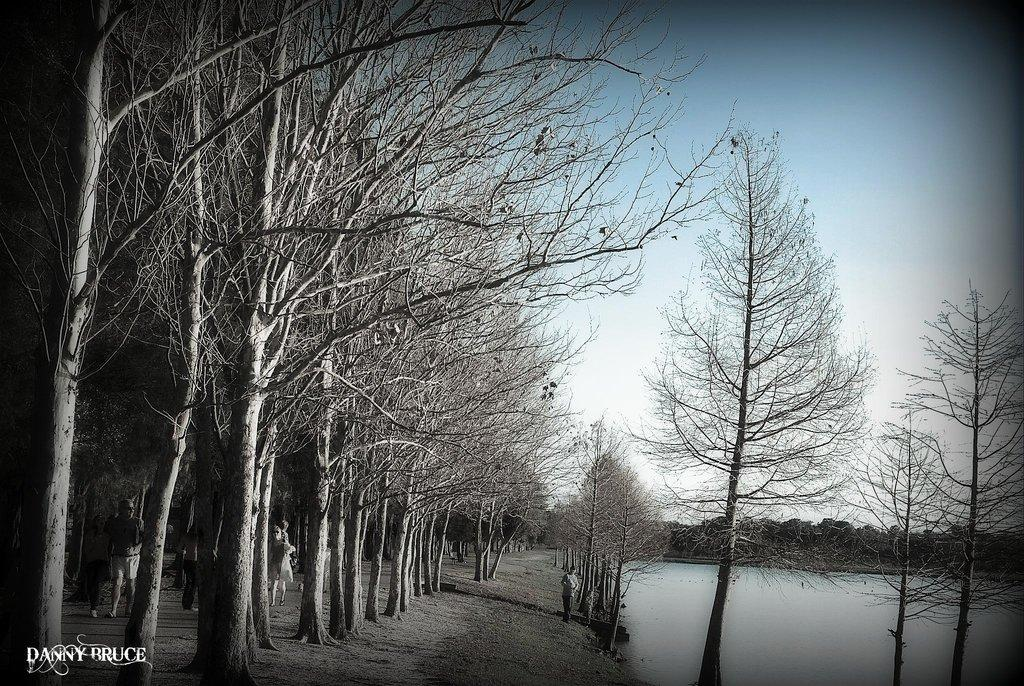What type of vegetation is on the right side of the image? There are trees on the right side of the image. What natural feature is located next to the trees on the right side of the image? There is a water body on the right side of the image. What is the person in the center of the image doing? A person is walking on the shore in the center of the image. What type of vegetation is on the left side of the image? There are trees on the left side of the image. What else can be seen on the left side of the image? There are people on the left side of the image. How would you describe the weather in the image? The sky is sunny in the image. How does the person in the image measure the temperature of the soup? There is no soup present in the image, so the person cannot measure its temperature. What type of hearing aid is the person on the left side of the image using? There is no mention of a hearing aid or any hearing-related issues in the image. 